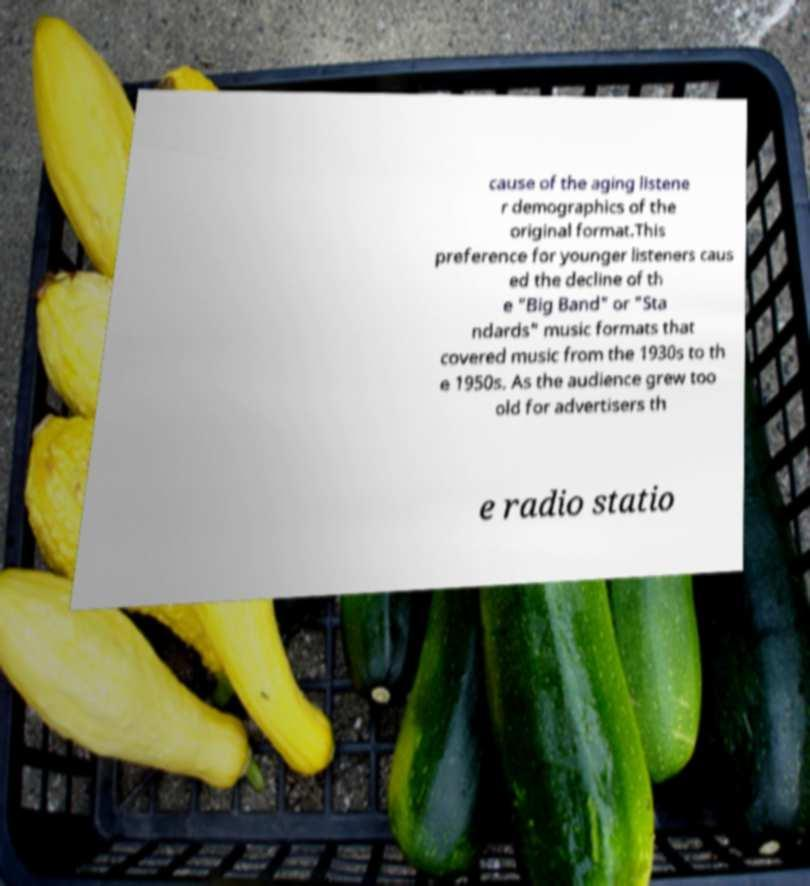Please read and relay the text visible in this image. What does it say? cause of the aging listene r demographics of the original format.This preference for younger listeners caus ed the decline of th e "Big Band" or "Sta ndards" music formats that covered music from the 1930s to th e 1950s. As the audience grew too old for advertisers th e radio statio 